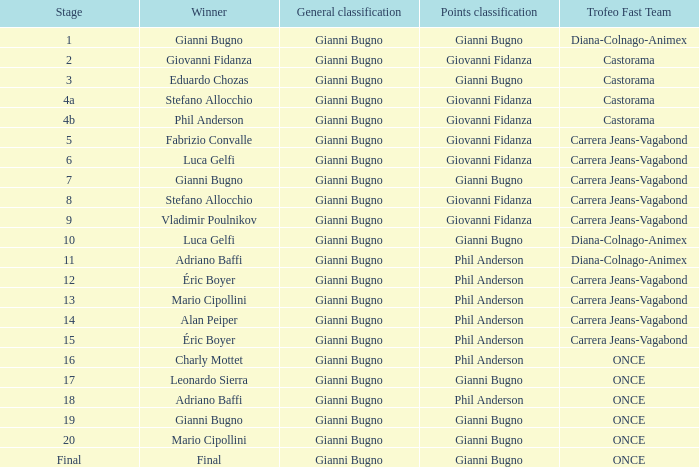Who is the winner when the trofeo fast team is carrera jeans-vagabond in stage 5? Fabrizio Convalle. 